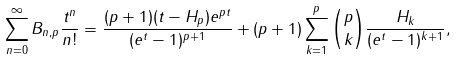<formula> <loc_0><loc_0><loc_500><loc_500>\sum _ { n = 0 } ^ { \infty } B _ { n , p } \frac { t ^ { n } } { n ! } = \frac { ( p + 1 ) ( t - H _ { p } ) e ^ { p t } } { ( e ^ { t } - 1 ) ^ { p + 1 } } + ( p + 1 ) \sum _ { k = 1 } ^ { p } \binom { p } { k } \frac { H _ { k } } { ( e ^ { t } - 1 ) ^ { k + 1 } } ,</formula> 